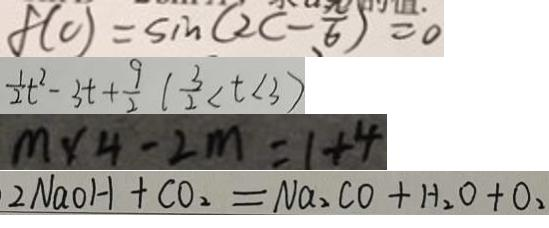Convert formula to latex. <formula><loc_0><loc_0><loc_500><loc_500>f ( c ) = \sin ( 2 c - \frac { \pi } { 6 } ) = 0 
 \frac { 1 } { 2 } t ^ { 2 } - 3 t + \frac { 9 } { 2 } ( \frac { 3 } { 2 } < t < 3 ) 
 m \times 4 - 2 m = 1 + 4 
 2 N a O H + C O _ { 2 } = N a _ { 2 } C O + H _ { 2 } O + O _ { 2 }</formula> 